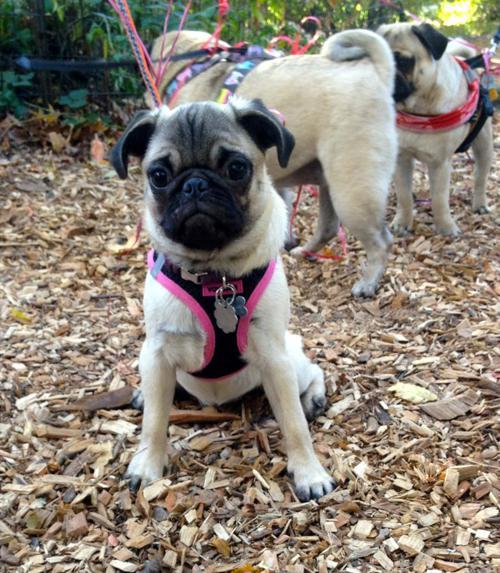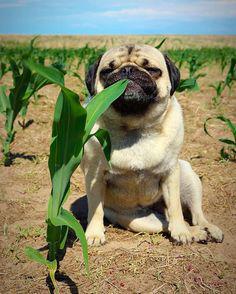The first image is the image on the left, the second image is the image on the right. For the images shown, is this caption "An image shows multiple pug dogs wearing harnesses." true? Answer yes or no. Yes. The first image is the image on the left, the second image is the image on the right. Evaluate the accuracy of this statement regarding the images: "A group of dogs is near a wooden fence in one of the images.". Is it true? Answer yes or no. No. 